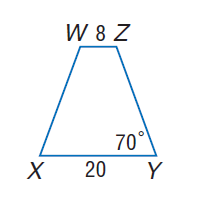Question: For isosceles trapezoid X Y Z W, find m \angle Z.
Choices:
A. 70
B. 90
C. 110
D. 250
Answer with the letter. Answer: C Question: For isosceles trapezoid X Y Z W, find the length of the median.
Choices:
A. 14
B. 16
C. 28
D. 32
Answer with the letter. Answer: A 